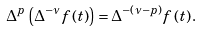Convert formula to latex. <formula><loc_0><loc_0><loc_500><loc_500>\Delta ^ { p } \left ( \Delta ^ { - \nu } f \left ( t \right ) \right ) = \Delta ^ { - \left ( \nu - p \right ) } f \left ( t \right ) .</formula> 